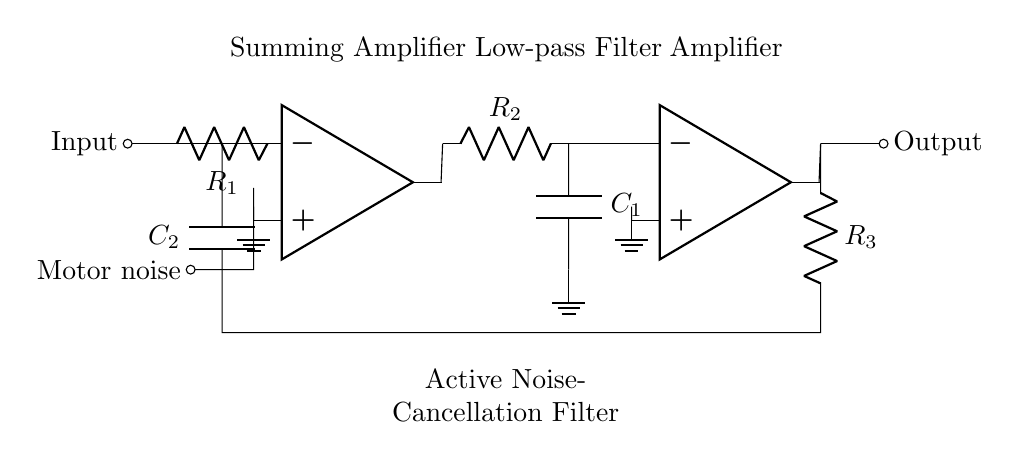What type of filter is used in this circuit? The circuit employs an active noise-cancellation filter, which is specifically designed to target and reduce noise from the motor in the cleaning equipment. This is indicated by the label on the diagram.
Answer: Active noise-cancellation filter What components are present in the summing amplifier? The summing amplifier includes an operational amplifier and a resistor labeled R1 connected to the input signal. The negative terminal of the op-amp connects back to the input through this resistor and the positive terminal is grounded.
Answer: Operational amplifier and R1 Which component acts as the low-pass filter? The low-pass filter in this circuit is formed by the resistor R2 and capacitor C1, which are connected in series, allowing lower frequency signals to pass while attenuating higher frequencies.
Answer: R2 and C1 What is the role of the second operational amplifier? The second operational amplifier amplifies the filtered signal from the low-pass filter before it is sent to the output, ensuring the signal strength is sufficient for further processing or transmission.
Answer: Amplification How is feedback applied in this circuit? Feedback is provided through the resistor R3, which connects from the output of the second operational amplifier back into the circuit, creating a feedback loop that helps stabilize and control the gain of the amplifier system.
Answer: Through R3 